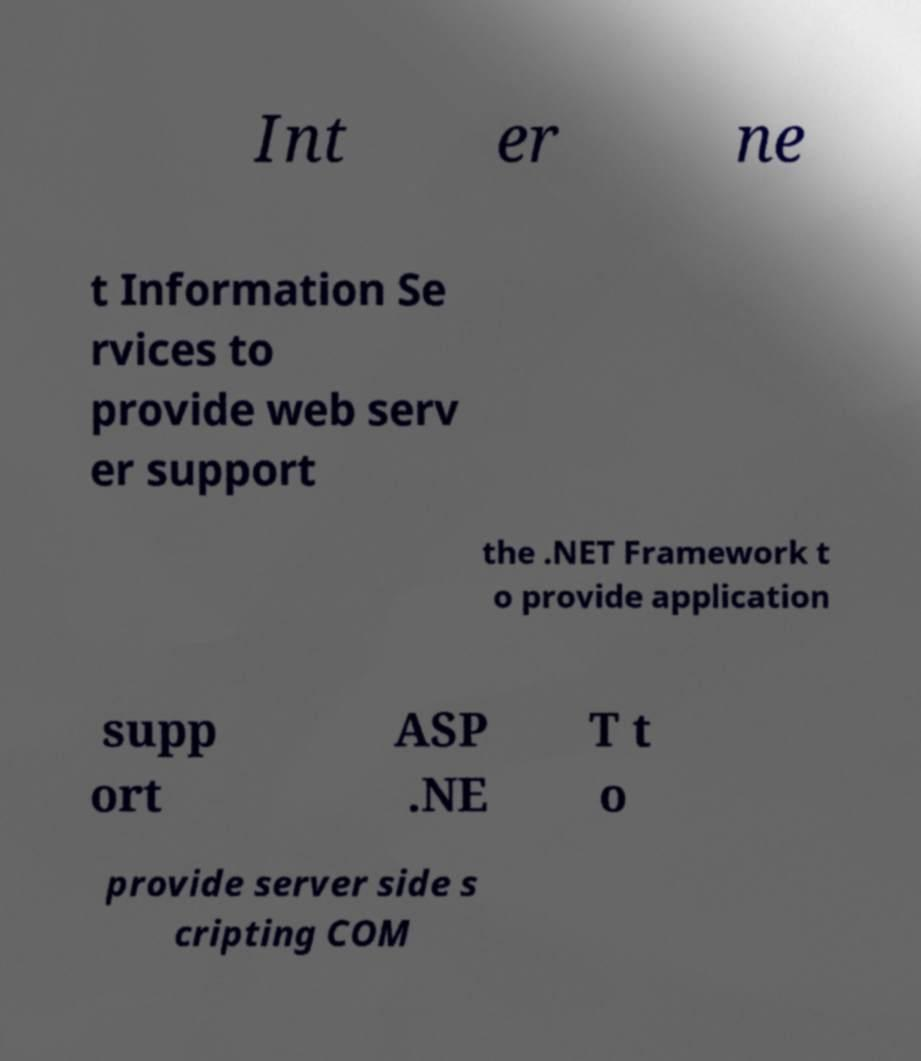Please identify and transcribe the text found in this image. Int er ne t Information Se rvices to provide web serv er support the .NET Framework t o provide application supp ort ASP .NE T t o provide server side s cripting COM 